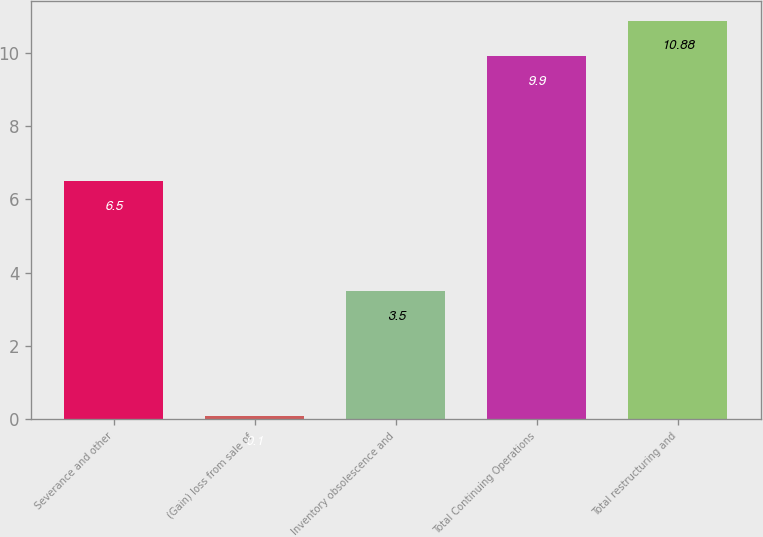Convert chart to OTSL. <chart><loc_0><loc_0><loc_500><loc_500><bar_chart><fcel>Severance and other<fcel>(Gain) loss from sale of<fcel>Inventory obsolescence and<fcel>Total Continuing Operations<fcel>Total restructuring and<nl><fcel>6.5<fcel>0.1<fcel>3.5<fcel>9.9<fcel>10.88<nl></chart> 